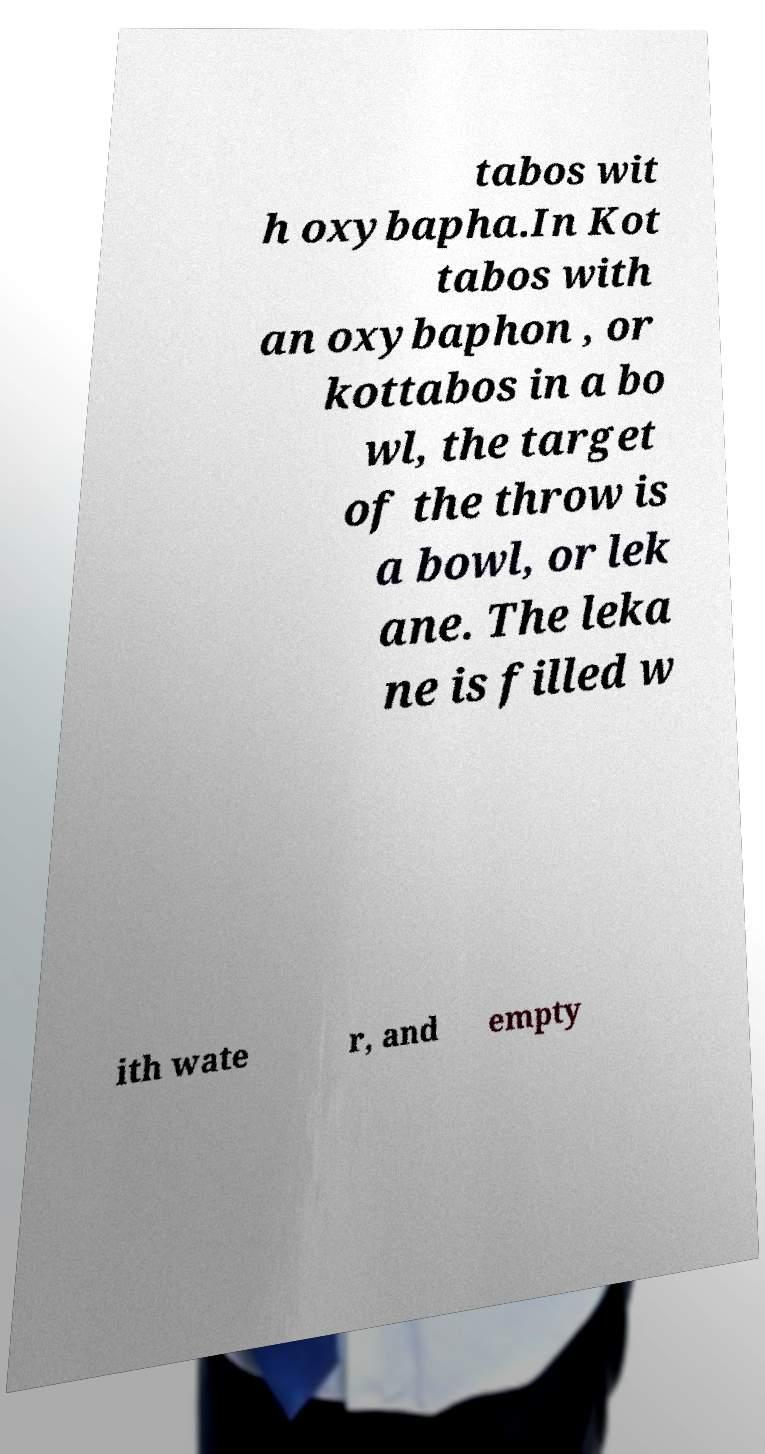I need the written content from this picture converted into text. Can you do that? tabos wit h oxybapha.In Kot tabos with an oxybaphon , or kottabos in a bo wl, the target of the throw is a bowl, or lek ane. The leka ne is filled w ith wate r, and empty 